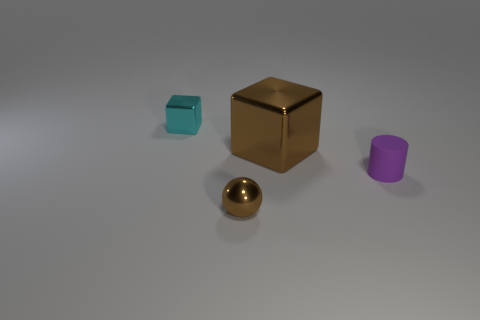Add 4 big green blocks. How many objects exist? 8 Subtract 1 balls. How many balls are left? 0 Subtract all cyan blocks. How many blocks are left? 1 Subtract all spheres. How many objects are left? 3 Subtract all blue cubes. Subtract all gray spheres. How many cubes are left? 2 Subtract all green balls. How many brown blocks are left? 1 Subtract all small metal cubes. Subtract all small metallic objects. How many objects are left? 1 Add 4 tiny matte cylinders. How many tiny matte cylinders are left? 5 Add 2 tiny yellow rubber blocks. How many tiny yellow rubber blocks exist? 2 Subtract 0 cyan spheres. How many objects are left? 4 